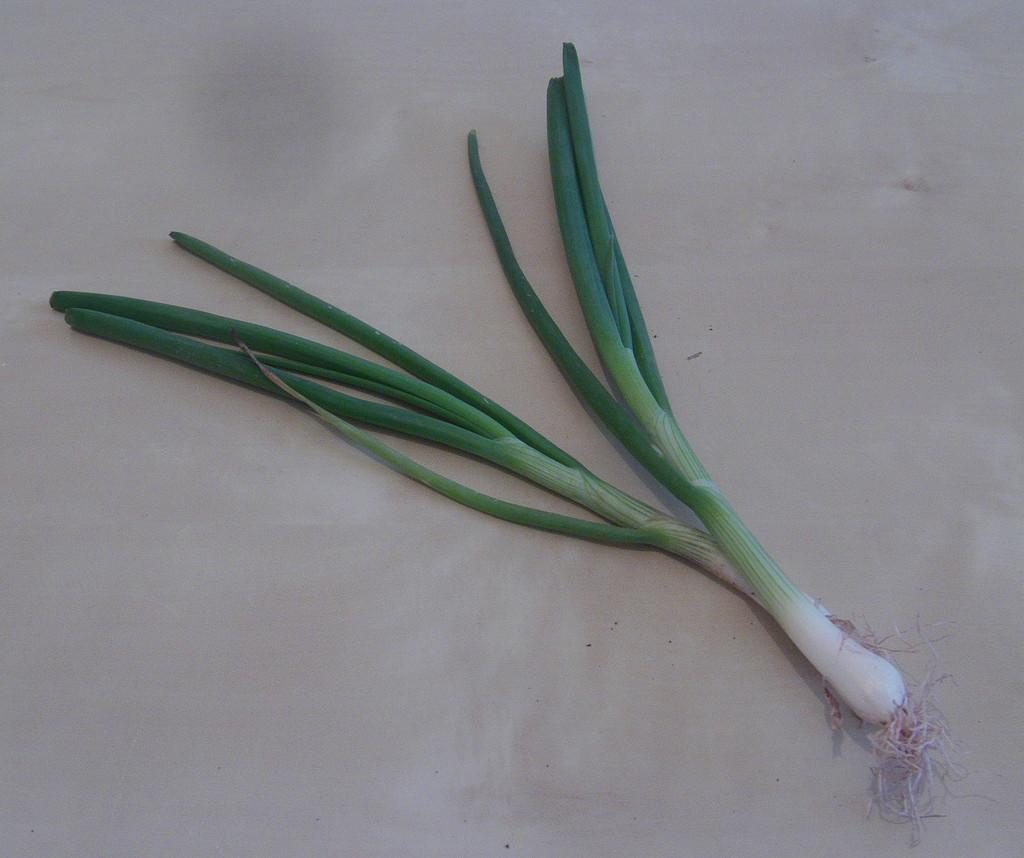What type of vegetables are in the image? There are two green spring onions in the image. What color is the surface on which the spring onions are placed? The surface is white. What might the white surface represent in the image? The white surface resembles a floor. What type of leather material is visible on the spring onions in the image? There is no leather material present on the spring onions in the image. What is the zinc content of the spring onions in the image? There is no information about the zinc content of the spring onions in the image. 